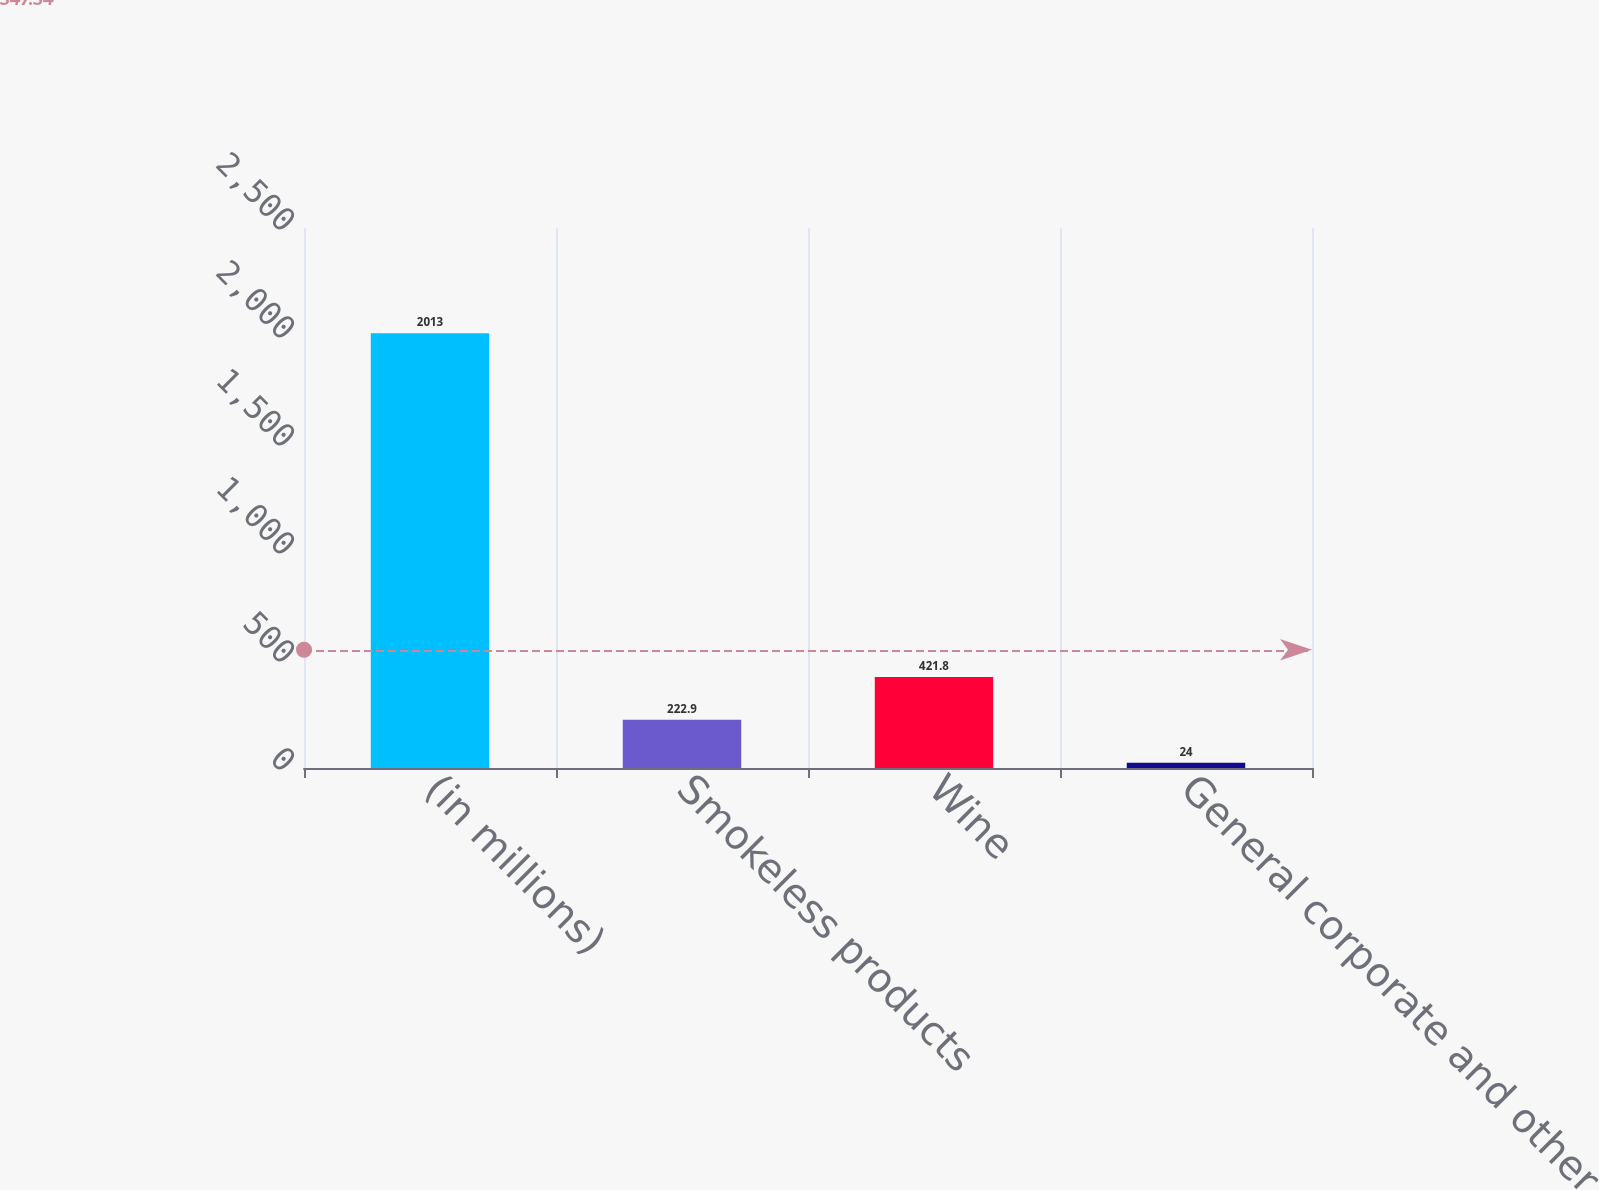<chart> <loc_0><loc_0><loc_500><loc_500><bar_chart><fcel>(in millions)<fcel>Smokeless products<fcel>Wine<fcel>General corporate and other<nl><fcel>2013<fcel>222.9<fcel>421.8<fcel>24<nl></chart> 